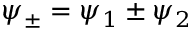Convert formula to latex. <formula><loc_0><loc_0><loc_500><loc_500>\psi _ { \pm } = \psi _ { 1 } \pm \psi _ { 2 }</formula> 